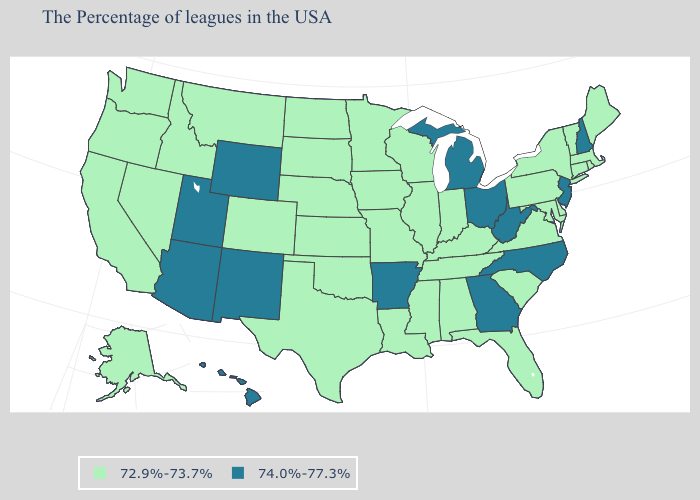How many symbols are there in the legend?
Be succinct. 2. Does the first symbol in the legend represent the smallest category?
Be succinct. Yes. Name the states that have a value in the range 74.0%-77.3%?
Keep it brief. New Hampshire, New Jersey, North Carolina, West Virginia, Ohio, Georgia, Michigan, Arkansas, Wyoming, New Mexico, Utah, Arizona, Hawaii. How many symbols are there in the legend?
Concise answer only. 2. What is the value of Nevada?
Write a very short answer. 72.9%-73.7%. What is the value of Arkansas?
Be succinct. 74.0%-77.3%. What is the value of Connecticut?
Write a very short answer. 72.9%-73.7%. Name the states that have a value in the range 72.9%-73.7%?
Keep it brief. Maine, Massachusetts, Rhode Island, Vermont, Connecticut, New York, Delaware, Maryland, Pennsylvania, Virginia, South Carolina, Florida, Kentucky, Indiana, Alabama, Tennessee, Wisconsin, Illinois, Mississippi, Louisiana, Missouri, Minnesota, Iowa, Kansas, Nebraska, Oklahoma, Texas, South Dakota, North Dakota, Colorado, Montana, Idaho, Nevada, California, Washington, Oregon, Alaska. What is the lowest value in the South?
Be succinct. 72.9%-73.7%. Which states have the highest value in the USA?
Answer briefly. New Hampshire, New Jersey, North Carolina, West Virginia, Ohio, Georgia, Michigan, Arkansas, Wyoming, New Mexico, Utah, Arizona, Hawaii. Name the states that have a value in the range 72.9%-73.7%?
Short answer required. Maine, Massachusetts, Rhode Island, Vermont, Connecticut, New York, Delaware, Maryland, Pennsylvania, Virginia, South Carolina, Florida, Kentucky, Indiana, Alabama, Tennessee, Wisconsin, Illinois, Mississippi, Louisiana, Missouri, Minnesota, Iowa, Kansas, Nebraska, Oklahoma, Texas, South Dakota, North Dakota, Colorado, Montana, Idaho, Nevada, California, Washington, Oregon, Alaska. What is the value of Pennsylvania?
Write a very short answer. 72.9%-73.7%. Does Tennessee have a lower value than Indiana?
Concise answer only. No. Which states have the lowest value in the USA?
Write a very short answer. Maine, Massachusetts, Rhode Island, Vermont, Connecticut, New York, Delaware, Maryland, Pennsylvania, Virginia, South Carolina, Florida, Kentucky, Indiana, Alabama, Tennessee, Wisconsin, Illinois, Mississippi, Louisiana, Missouri, Minnesota, Iowa, Kansas, Nebraska, Oklahoma, Texas, South Dakota, North Dakota, Colorado, Montana, Idaho, Nevada, California, Washington, Oregon, Alaska. Does Pennsylvania have the same value as Alabama?
Quick response, please. Yes. 